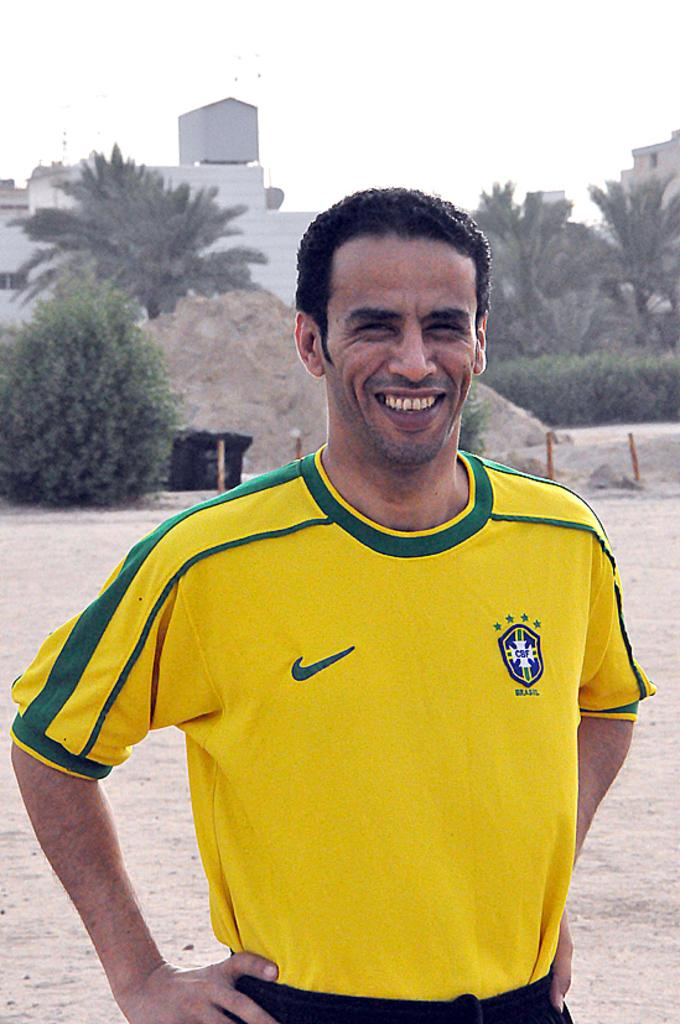What is the main subject of the image? There is a man in the image. What is the man wearing? The man is wearing a yellow t-shirt and trousers. What is the man's facial expression? The man is smiling. What can be seen in the background of the image? There are trees, buildings, land, and the sky visible in the background of the image. How does the man control the loaf in the image? There is no loaf present in the image, so it is not possible to determine how the man might control it. 